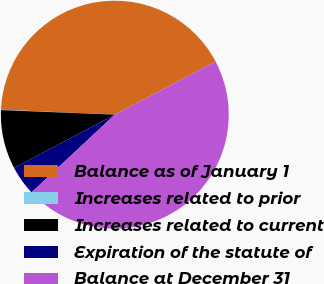Convert chart. <chart><loc_0><loc_0><loc_500><loc_500><pie_chart><fcel>Balance as of January 1<fcel>Increases related to prior<fcel>Increases related to current<fcel>Expiration of the statute of<fcel>Balance at December 31<nl><fcel>41.6%<fcel>0.05%<fcel>8.38%<fcel>4.21%<fcel>45.76%<nl></chart> 